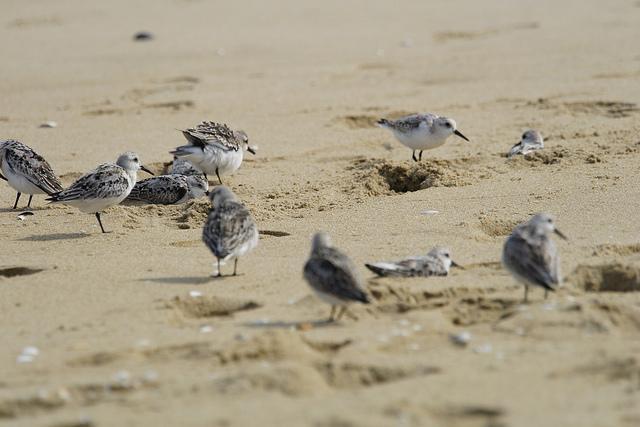What do people usually feed these animals?
Choose the right answer from the provided options to respond to the question.
Options: Bread, dogs, cats, chili. Bread. 